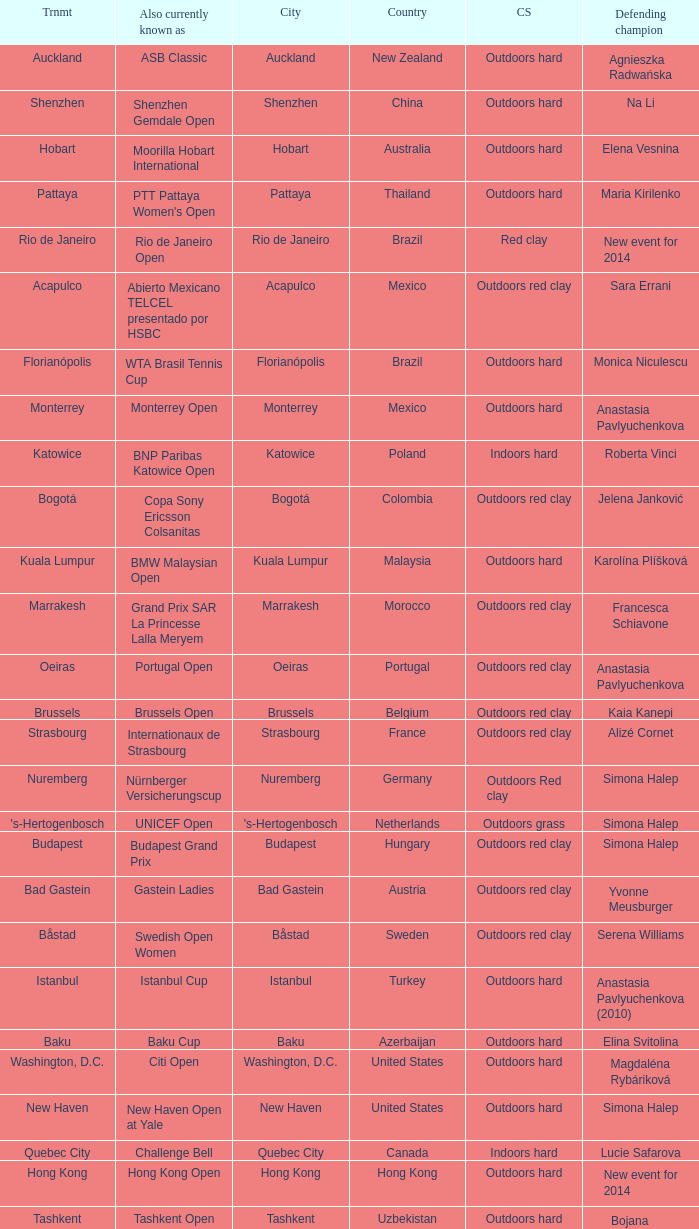How many tournaments are also currently known as the hp open? 1.0. 